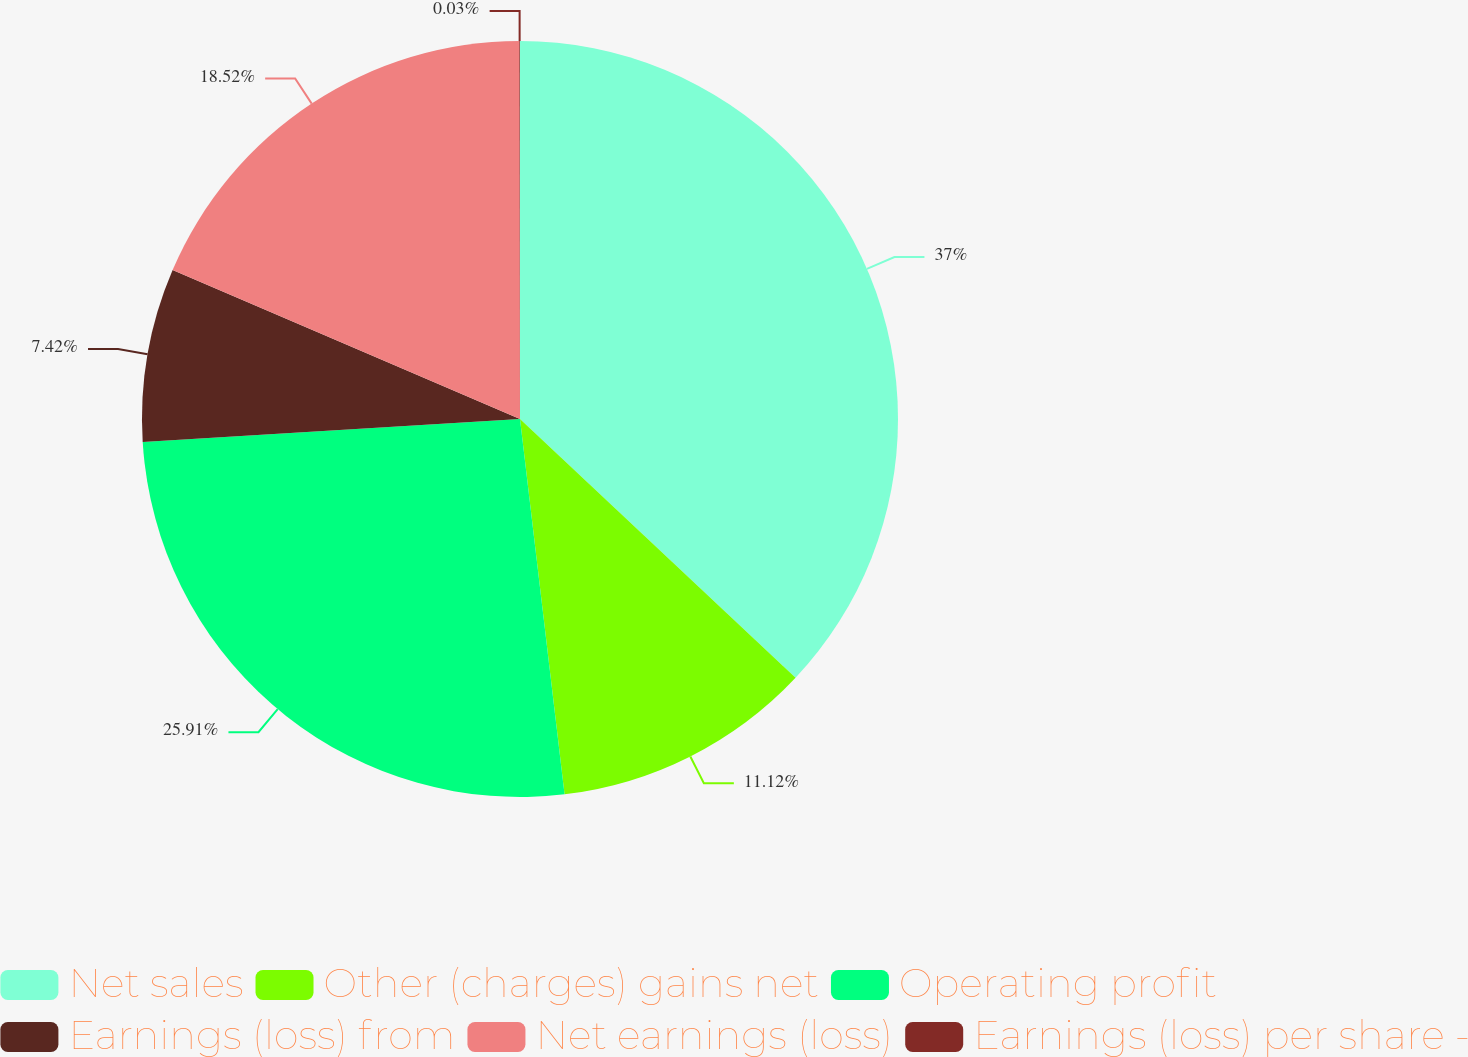<chart> <loc_0><loc_0><loc_500><loc_500><pie_chart><fcel>Net sales<fcel>Other (charges) gains net<fcel>Operating profit<fcel>Earnings (loss) from<fcel>Net earnings (loss)<fcel>Earnings (loss) per share -<nl><fcel>37.0%<fcel>11.12%<fcel>25.91%<fcel>7.42%<fcel>18.52%<fcel>0.03%<nl></chart> 